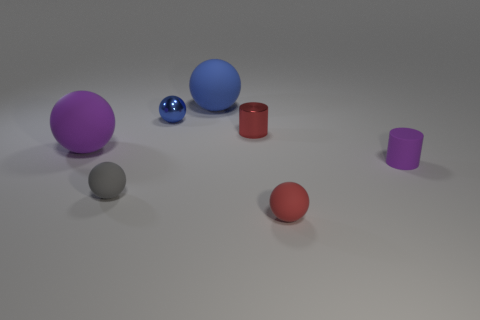Subtract all gray cylinders. How many blue balls are left? 2 Subtract all red rubber spheres. How many spheres are left? 4 Subtract all purple spheres. How many spheres are left? 4 Subtract 1 balls. How many balls are left? 4 Add 1 matte spheres. How many objects exist? 8 Subtract all yellow balls. Subtract all gray blocks. How many balls are left? 5 Subtract all cylinders. How many objects are left? 5 Subtract all purple rubber cylinders. Subtract all blue objects. How many objects are left? 4 Add 7 big purple objects. How many big purple objects are left? 8 Add 6 yellow matte spheres. How many yellow matte spheres exist? 6 